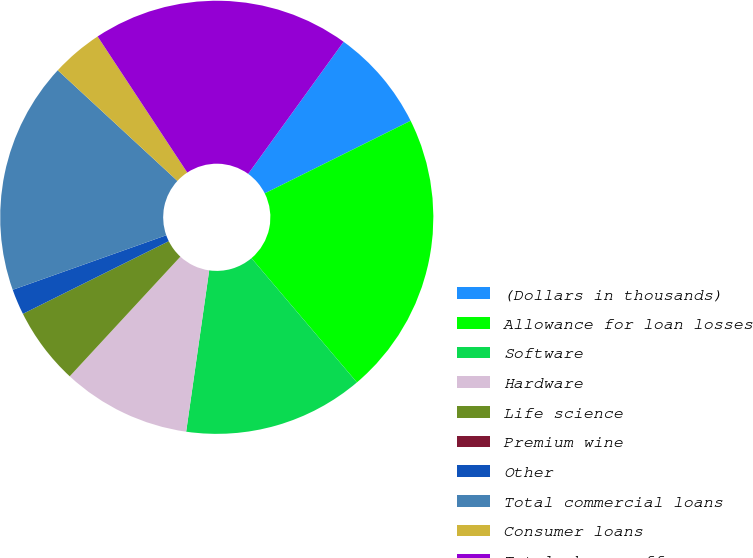Convert chart to OTSL. <chart><loc_0><loc_0><loc_500><loc_500><pie_chart><fcel>(Dollars in thousands)<fcel>Allowance for loan losses<fcel>Software<fcel>Hardware<fcel>Life science<fcel>Premium wine<fcel>Other<fcel>Total commercial loans<fcel>Consumer loans<fcel>Total charge-offs<nl><fcel>7.69%<fcel>21.15%<fcel>13.46%<fcel>9.62%<fcel>5.77%<fcel>0.0%<fcel>1.92%<fcel>17.31%<fcel>3.85%<fcel>19.23%<nl></chart> 